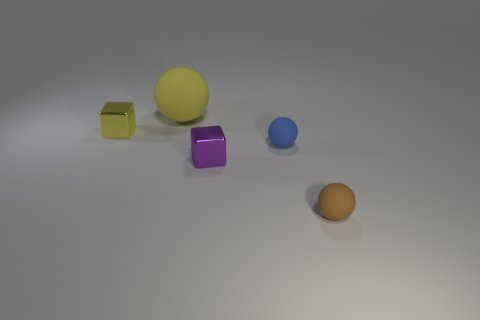Subtract all gray cubes. Subtract all blue cylinders. How many cubes are left? 2 Add 2 brown matte balls. How many objects exist? 7 Subtract all blocks. How many objects are left? 3 Subtract all yellow spheres. Subtract all blue matte things. How many objects are left? 3 Add 4 brown rubber spheres. How many brown rubber spheres are left? 5 Add 4 yellow matte objects. How many yellow matte objects exist? 5 Subtract 0 red cubes. How many objects are left? 5 